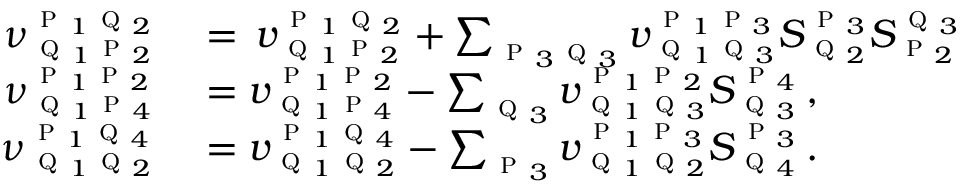Convert formula to latex. <formula><loc_0><loc_0><loc_500><loc_500>\begin{array} { r l } { \nu _ { q _ { 1 } p _ { 2 } } ^ { p _ { 1 } q _ { 2 } } } & = \, v _ { q _ { 1 } p _ { 2 } } ^ { p _ { 1 } q _ { 2 } } + \sum _ { p _ { 3 } q _ { 3 } } v _ { q _ { 1 } q _ { 3 } } ^ { p _ { 1 } p _ { 3 } } S _ { q _ { 2 } } ^ { p _ { 3 } } S _ { p _ { 2 } } ^ { q _ { 3 } } } \\ { \nu _ { q _ { 1 } p _ { 4 } } ^ { p _ { 1 } p _ { 2 } } } & = v _ { q _ { 1 } p _ { 4 } } ^ { p _ { 1 } p _ { 2 } } - \sum _ { q _ { 3 } } v _ { q _ { 1 } q _ { 3 } } ^ { p _ { 1 } p _ { 2 } } S _ { q _ { 3 } } ^ { p _ { 4 } } \, , } \\ { \nu _ { q _ { 1 } q _ { 2 } } ^ { p _ { 1 } q _ { 4 } } } & = v _ { q _ { 1 } q _ { 2 } } ^ { p _ { 1 } q _ { 4 } } - \sum _ { p _ { 3 } } v _ { q _ { 1 } q _ { 2 } } ^ { p _ { 1 } p _ { 3 } } S _ { q _ { 4 } } ^ { p _ { 3 } } \, . } \end{array}</formula> 